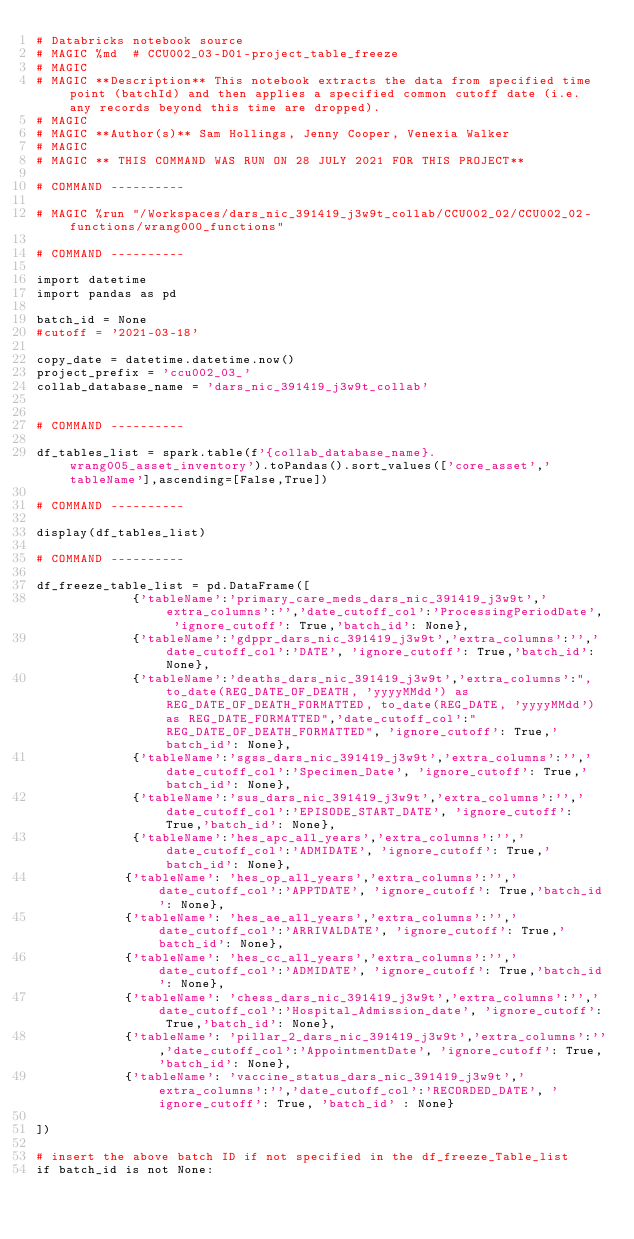Convert code to text. <code><loc_0><loc_0><loc_500><loc_500><_Python_># Databricks notebook source
# MAGIC %md  # CCU002_03-D01-project_table_freeze
# MAGIC 
# MAGIC **Description** This notebook extracts the data from specified time point (batchId) and then applies a specified common cutoff date (i.e. any records beyond this time are dropped).
# MAGIC 
# MAGIC **Author(s)** Sam Hollings, Jenny Cooper, Venexia Walker
# MAGIC 
# MAGIC ** THIS COMMAND WAS RUN ON 28 JULY 2021 FOR THIS PROJECT**

# COMMAND ----------

# MAGIC %run "/Workspaces/dars_nic_391419_j3w9t_collab/CCU002_02/CCU002_02-functions/wrang000_functions"

# COMMAND ----------

import datetime 
import pandas as pd

batch_id = None
#cutoff = '2021-03-18'

copy_date = datetime.datetime.now()
project_prefix = 'ccu002_03_'
collab_database_name = 'dars_nic_391419_j3w9t_collab'


# COMMAND ----------

df_tables_list = spark.table(f'{collab_database_name}.wrang005_asset_inventory').toPandas().sort_values(['core_asset','tableName'],ascending=[False,True])

# COMMAND ----------

display(df_tables_list)

# COMMAND ----------

df_freeze_table_list = pd.DataFrame([
             {'tableName':'primary_care_meds_dars_nic_391419_j3w9t','extra_columns':'','date_cutoff_col':'ProcessingPeriodDate', 'ignore_cutoff': True,'batch_id': None},
             {'tableName':'gdppr_dars_nic_391419_j3w9t','extra_columns':'','date_cutoff_col':'DATE', 'ignore_cutoff': True,'batch_id': None},
             {'tableName':'deaths_dars_nic_391419_j3w9t','extra_columns':", to_date(REG_DATE_OF_DEATH, 'yyyyMMdd') as REG_DATE_OF_DEATH_FORMATTED, to_date(REG_DATE, 'yyyyMMdd') as REG_DATE_FORMATTED",'date_cutoff_col':"REG_DATE_OF_DEATH_FORMATTED", 'ignore_cutoff': True,'batch_id': None},
             {'tableName':'sgss_dars_nic_391419_j3w9t','extra_columns':'','date_cutoff_col':'Specimen_Date', 'ignore_cutoff': True,'batch_id': None}, 
             {'tableName':'sus_dars_nic_391419_j3w9t','extra_columns':'','date_cutoff_col':'EPISODE_START_DATE', 'ignore_cutoff': True,'batch_id': None},
             {'tableName':'hes_apc_all_years','extra_columns':'','date_cutoff_col':'ADMIDATE', 'ignore_cutoff': True,'batch_id': None},
            {'tableName': 'hes_op_all_years','extra_columns':'','date_cutoff_col':'APPTDATE', 'ignore_cutoff': True,'batch_id': None},
            {'tableName': 'hes_ae_all_years','extra_columns':'','date_cutoff_col':'ARRIVALDATE', 'ignore_cutoff': True,'batch_id': None},
            {'tableName': 'hes_cc_all_years','extra_columns':'','date_cutoff_col':'ADMIDATE', 'ignore_cutoff': True,'batch_id': None},
            {'tableName': 'chess_dars_nic_391419_j3w9t','extra_columns':'','date_cutoff_col':'Hospital_Admission_date', 'ignore_cutoff': True,'batch_id': None},
            {'tableName': 'pillar_2_dars_nic_391419_j3w9t','extra_columns':'','date_cutoff_col':'AppointmentDate', 'ignore_cutoff': True,'batch_id': None},
            {'tableName': 'vaccine_status_dars_nic_391419_j3w9t','extra_columns':'','date_cutoff_col':'RECORDED_DATE', 'ignore_cutoff': True, 'batch_id' : None}
    
])

# insert the above batch ID if not specified in the df_freeze_Table_list
if batch_id is not None:</code> 